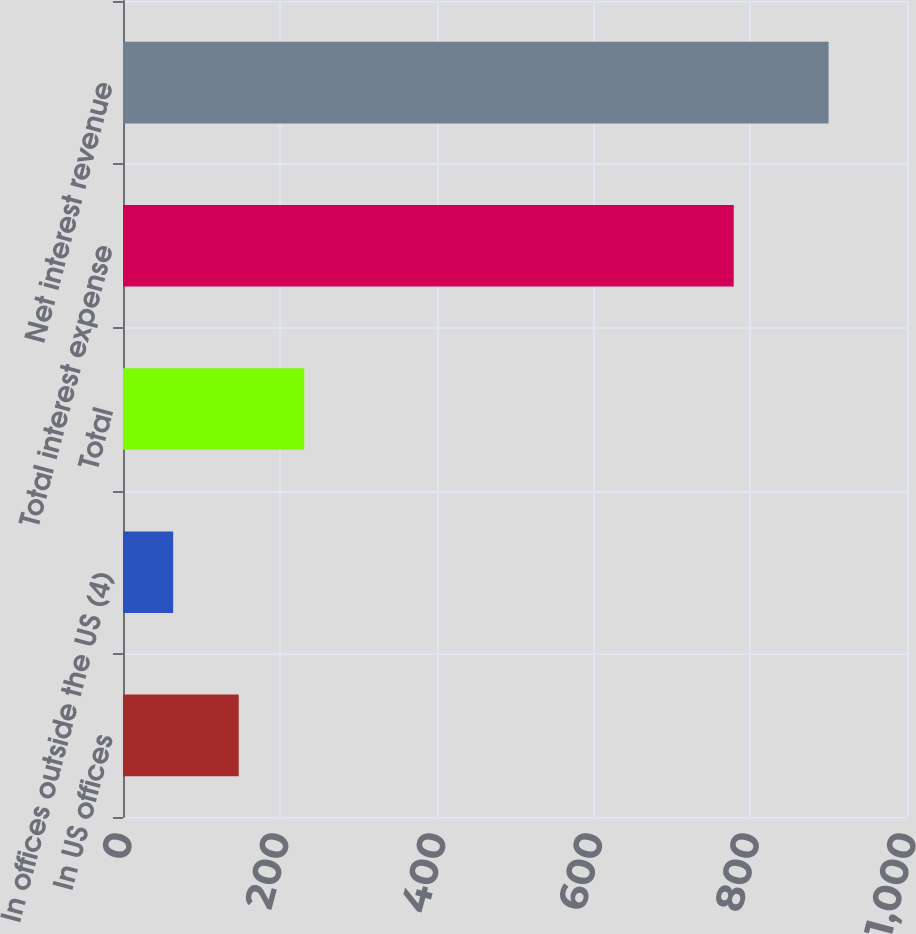Convert chart to OTSL. <chart><loc_0><loc_0><loc_500><loc_500><bar_chart><fcel>In US offices<fcel>In offices outside the US (4)<fcel>Total<fcel>Total interest expense<fcel>Net interest revenue<nl><fcel>147.6<fcel>64<fcel>231.2<fcel>779<fcel>900<nl></chart> 